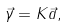<formula> <loc_0><loc_0><loc_500><loc_500>\vec { \gamma } = K \vec { a } ,</formula> 